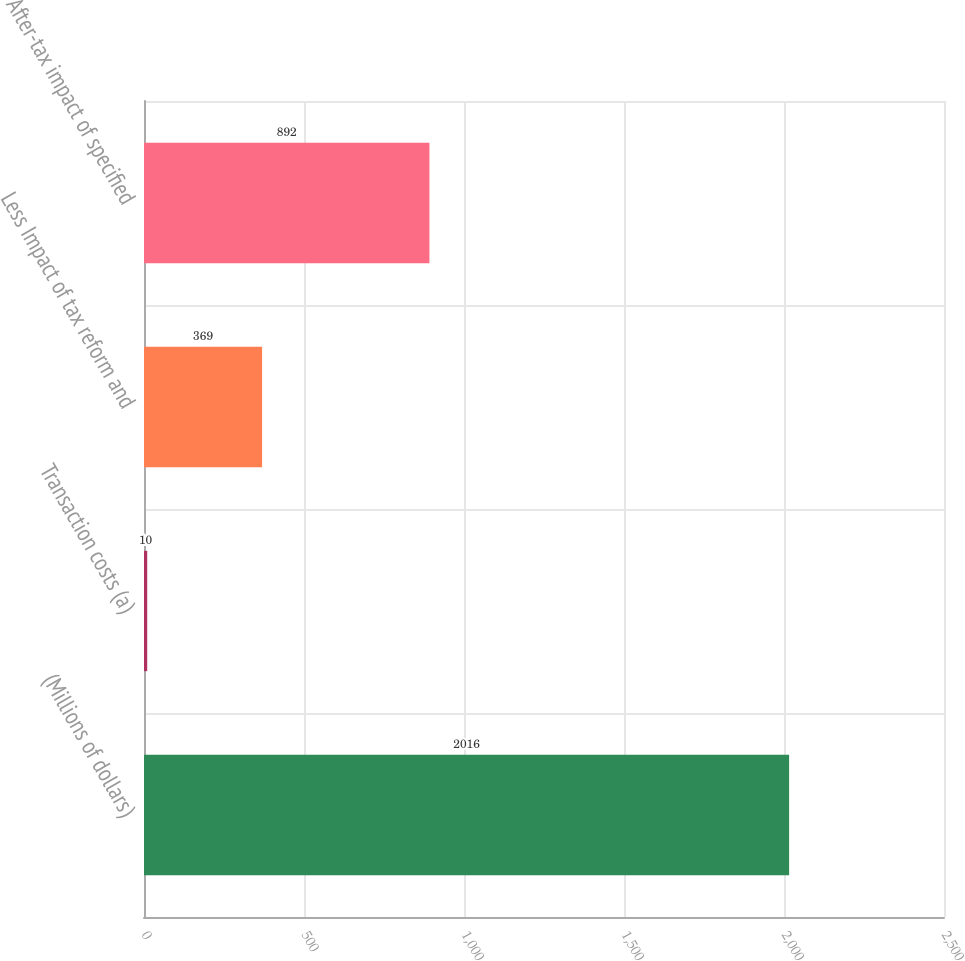<chart> <loc_0><loc_0><loc_500><loc_500><bar_chart><fcel>(Millions of dollars)<fcel>Transaction costs (a)<fcel>Less Impact of tax reform and<fcel>After-tax impact of specified<nl><fcel>2016<fcel>10<fcel>369<fcel>892<nl></chart> 